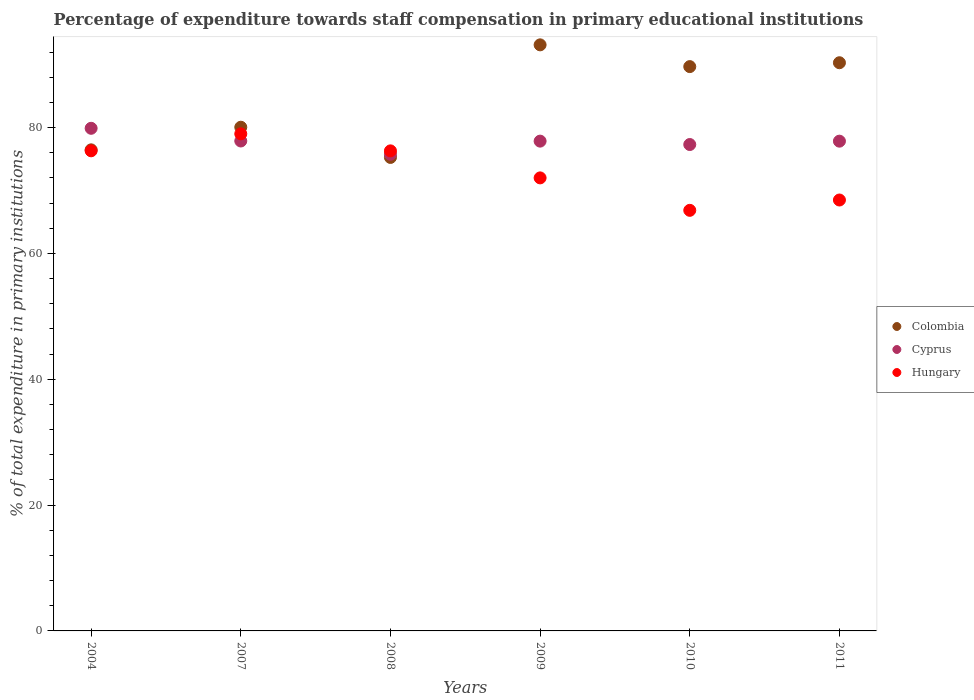What is the percentage of expenditure towards staff compensation in Cyprus in 2009?
Provide a succinct answer. 77.86. Across all years, what is the maximum percentage of expenditure towards staff compensation in Cyprus?
Offer a terse response. 79.89. Across all years, what is the minimum percentage of expenditure towards staff compensation in Colombia?
Offer a terse response. 75.26. In which year was the percentage of expenditure towards staff compensation in Colombia maximum?
Ensure brevity in your answer.  2009. In which year was the percentage of expenditure towards staff compensation in Colombia minimum?
Provide a succinct answer. 2008. What is the total percentage of expenditure towards staff compensation in Colombia in the graph?
Your answer should be compact. 504.98. What is the difference between the percentage of expenditure towards staff compensation in Colombia in 2004 and that in 2008?
Make the answer very short. 1.21. What is the difference between the percentage of expenditure towards staff compensation in Cyprus in 2011 and the percentage of expenditure towards staff compensation in Hungary in 2004?
Keep it short and to the point. 1.53. What is the average percentage of expenditure towards staff compensation in Hungary per year?
Provide a short and direct response. 73.17. In the year 2011, what is the difference between the percentage of expenditure towards staff compensation in Hungary and percentage of expenditure towards staff compensation in Cyprus?
Your response must be concise. -9.35. In how many years, is the percentage of expenditure towards staff compensation in Colombia greater than 84 %?
Your response must be concise. 3. What is the ratio of the percentage of expenditure towards staff compensation in Colombia in 2004 to that in 2010?
Give a very brief answer. 0.85. Is the percentage of expenditure towards staff compensation in Cyprus in 2008 less than that in 2011?
Ensure brevity in your answer.  Yes. What is the difference between the highest and the second highest percentage of expenditure towards staff compensation in Hungary?
Make the answer very short. 2.7. What is the difference between the highest and the lowest percentage of expenditure towards staff compensation in Cyprus?
Your answer should be very brief. 4.13. In how many years, is the percentage of expenditure towards staff compensation in Hungary greater than the average percentage of expenditure towards staff compensation in Hungary taken over all years?
Your answer should be very brief. 3. Does the percentage of expenditure towards staff compensation in Colombia monotonically increase over the years?
Your answer should be very brief. No. Is the percentage of expenditure towards staff compensation in Hungary strictly less than the percentage of expenditure towards staff compensation in Cyprus over the years?
Keep it short and to the point. No. How many years are there in the graph?
Provide a short and direct response. 6. Are the values on the major ticks of Y-axis written in scientific E-notation?
Your answer should be compact. No. Does the graph contain any zero values?
Make the answer very short. No. Where does the legend appear in the graph?
Provide a succinct answer. Center right. How many legend labels are there?
Offer a very short reply. 3. How are the legend labels stacked?
Offer a very short reply. Vertical. What is the title of the graph?
Provide a succinct answer. Percentage of expenditure towards staff compensation in primary educational institutions. What is the label or title of the Y-axis?
Your answer should be compact. % of total expenditure in primary institutions. What is the % of total expenditure in primary institutions of Colombia in 2004?
Provide a succinct answer. 76.47. What is the % of total expenditure in primary institutions of Cyprus in 2004?
Ensure brevity in your answer.  79.89. What is the % of total expenditure in primary institutions of Hungary in 2004?
Offer a terse response. 76.32. What is the % of total expenditure in primary institutions of Colombia in 2007?
Your response must be concise. 80.07. What is the % of total expenditure in primary institutions in Cyprus in 2007?
Your response must be concise. 77.88. What is the % of total expenditure in primary institutions in Hungary in 2007?
Make the answer very short. 79.01. What is the % of total expenditure in primary institutions of Colombia in 2008?
Give a very brief answer. 75.26. What is the % of total expenditure in primary institutions of Cyprus in 2008?
Give a very brief answer. 75.76. What is the % of total expenditure in primary institutions in Hungary in 2008?
Provide a succinct answer. 76.31. What is the % of total expenditure in primary institutions in Colombia in 2009?
Provide a succinct answer. 93.16. What is the % of total expenditure in primary institutions of Cyprus in 2009?
Your response must be concise. 77.86. What is the % of total expenditure in primary institutions in Hungary in 2009?
Provide a succinct answer. 72.01. What is the % of total expenditure in primary institutions in Colombia in 2010?
Provide a succinct answer. 89.7. What is the % of total expenditure in primary institutions of Cyprus in 2010?
Your answer should be very brief. 77.32. What is the % of total expenditure in primary institutions in Hungary in 2010?
Your response must be concise. 66.86. What is the % of total expenditure in primary institutions in Colombia in 2011?
Provide a succinct answer. 90.32. What is the % of total expenditure in primary institutions in Cyprus in 2011?
Your answer should be compact. 77.85. What is the % of total expenditure in primary institutions of Hungary in 2011?
Your response must be concise. 68.5. Across all years, what is the maximum % of total expenditure in primary institutions in Colombia?
Give a very brief answer. 93.16. Across all years, what is the maximum % of total expenditure in primary institutions in Cyprus?
Your response must be concise. 79.89. Across all years, what is the maximum % of total expenditure in primary institutions in Hungary?
Make the answer very short. 79.01. Across all years, what is the minimum % of total expenditure in primary institutions of Colombia?
Your answer should be very brief. 75.26. Across all years, what is the minimum % of total expenditure in primary institutions of Cyprus?
Offer a terse response. 75.76. Across all years, what is the minimum % of total expenditure in primary institutions of Hungary?
Your answer should be very brief. 66.86. What is the total % of total expenditure in primary institutions in Colombia in the graph?
Give a very brief answer. 504.98. What is the total % of total expenditure in primary institutions of Cyprus in the graph?
Ensure brevity in your answer.  466.55. What is the total % of total expenditure in primary institutions of Hungary in the graph?
Offer a very short reply. 439. What is the difference between the % of total expenditure in primary institutions of Colombia in 2004 and that in 2007?
Your response must be concise. -3.6. What is the difference between the % of total expenditure in primary institutions of Cyprus in 2004 and that in 2007?
Provide a succinct answer. 2.02. What is the difference between the % of total expenditure in primary institutions of Hungary in 2004 and that in 2007?
Ensure brevity in your answer.  -2.7. What is the difference between the % of total expenditure in primary institutions in Colombia in 2004 and that in 2008?
Provide a short and direct response. 1.21. What is the difference between the % of total expenditure in primary institutions in Cyprus in 2004 and that in 2008?
Your answer should be very brief. 4.13. What is the difference between the % of total expenditure in primary institutions of Hungary in 2004 and that in 2008?
Ensure brevity in your answer.  0.01. What is the difference between the % of total expenditure in primary institutions of Colombia in 2004 and that in 2009?
Give a very brief answer. -16.69. What is the difference between the % of total expenditure in primary institutions in Cyprus in 2004 and that in 2009?
Make the answer very short. 2.04. What is the difference between the % of total expenditure in primary institutions of Hungary in 2004 and that in 2009?
Provide a succinct answer. 4.31. What is the difference between the % of total expenditure in primary institutions in Colombia in 2004 and that in 2010?
Provide a short and direct response. -13.23. What is the difference between the % of total expenditure in primary institutions in Cyprus in 2004 and that in 2010?
Provide a succinct answer. 2.58. What is the difference between the % of total expenditure in primary institutions of Hungary in 2004 and that in 2010?
Offer a terse response. 9.46. What is the difference between the % of total expenditure in primary institutions of Colombia in 2004 and that in 2011?
Offer a very short reply. -13.85. What is the difference between the % of total expenditure in primary institutions in Cyprus in 2004 and that in 2011?
Provide a succinct answer. 2.04. What is the difference between the % of total expenditure in primary institutions in Hungary in 2004 and that in 2011?
Provide a succinct answer. 7.82. What is the difference between the % of total expenditure in primary institutions of Colombia in 2007 and that in 2008?
Give a very brief answer. 4.8. What is the difference between the % of total expenditure in primary institutions in Cyprus in 2007 and that in 2008?
Make the answer very short. 2.12. What is the difference between the % of total expenditure in primary institutions in Hungary in 2007 and that in 2008?
Your response must be concise. 2.71. What is the difference between the % of total expenditure in primary institutions of Colombia in 2007 and that in 2009?
Offer a terse response. -13.09. What is the difference between the % of total expenditure in primary institutions in Cyprus in 2007 and that in 2009?
Make the answer very short. 0.02. What is the difference between the % of total expenditure in primary institutions in Hungary in 2007 and that in 2009?
Your answer should be compact. 7. What is the difference between the % of total expenditure in primary institutions of Colombia in 2007 and that in 2010?
Offer a very short reply. -9.64. What is the difference between the % of total expenditure in primary institutions of Cyprus in 2007 and that in 2010?
Your answer should be very brief. 0.56. What is the difference between the % of total expenditure in primary institutions of Hungary in 2007 and that in 2010?
Offer a very short reply. 12.16. What is the difference between the % of total expenditure in primary institutions of Colombia in 2007 and that in 2011?
Your answer should be compact. -10.25. What is the difference between the % of total expenditure in primary institutions in Cyprus in 2007 and that in 2011?
Provide a short and direct response. 0.03. What is the difference between the % of total expenditure in primary institutions in Hungary in 2007 and that in 2011?
Your response must be concise. 10.52. What is the difference between the % of total expenditure in primary institutions in Colombia in 2008 and that in 2009?
Offer a very short reply. -17.9. What is the difference between the % of total expenditure in primary institutions in Cyprus in 2008 and that in 2009?
Offer a terse response. -2.09. What is the difference between the % of total expenditure in primary institutions of Hungary in 2008 and that in 2009?
Provide a succinct answer. 4.3. What is the difference between the % of total expenditure in primary institutions in Colombia in 2008 and that in 2010?
Your answer should be very brief. -14.44. What is the difference between the % of total expenditure in primary institutions in Cyprus in 2008 and that in 2010?
Give a very brief answer. -1.56. What is the difference between the % of total expenditure in primary institutions of Hungary in 2008 and that in 2010?
Offer a very short reply. 9.45. What is the difference between the % of total expenditure in primary institutions of Colombia in 2008 and that in 2011?
Your answer should be compact. -15.05. What is the difference between the % of total expenditure in primary institutions in Cyprus in 2008 and that in 2011?
Give a very brief answer. -2.09. What is the difference between the % of total expenditure in primary institutions of Hungary in 2008 and that in 2011?
Provide a succinct answer. 7.81. What is the difference between the % of total expenditure in primary institutions in Colombia in 2009 and that in 2010?
Keep it short and to the point. 3.46. What is the difference between the % of total expenditure in primary institutions of Cyprus in 2009 and that in 2010?
Provide a succinct answer. 0.54. What is the difference between the % of total expenditure in primary institutions of Hungary in 2009 and that in 2010?
Your answer should be compact. 5.16. What is the difference between the % of total expenditure in primary institutions of Colombia in 2009 and that in 2011?
Keep it short and to the point. 2.84. What is the difference between the % of total expenditure in primary institutions in Cyprus in 2009 and that in 2011?
Offer a very short reply. 0.01. What is the difference between the % of total expenditure in primary institutions in Hungary in 2009 and that in 2011?
Ensure brevity in your answer.  3.52. What is the difference between the % of total expenditure in primary institutions in Colombia in 2010 and that in 2011?
Your answer should be very brief. -0.62. What is the difference between the % of total expenditure in primary institutions of Cyprus in 2010 and that in 2011?
Your answer should be compact. -0.53. What is the difference between the % of total expenditure in primary institutions of Hungary in 2010 and that in 2011?
Your answer should be very brief. -1.64. What is the difference between the % of total expenditure in primary institutions of Colombia in 2004 and the % of total expenditure in primary institutions of Cyprus in 2007?
Give a very brief answer. -1.41. What is the difference between the % of total expenditure in primary institutions of Colombia in 2004 and the % of total expenditure in primary institutions of Hungary in 2007?
Provide a succinct answer. -2.54. What is the difference between the % of total expenditure in primary institutions in Cyprus in 2004 and the % of total expenditure in primary institutions in Hungary in 2007?
Provide a short and direct response. 0.88. What is the difference between the % of total expenditure in primary institutions of Colombia in 2004 and the % of total expenditure in primary institutions of Cyprus in 2008?
Your response must be concise. 0.71. What is the difference between the % of total expenditure in primary institutions in Colombia in 2004 and the % of total expenditure in primary institutions in Hungary in 2008?
Your answer should be compact. 0.16. What is the difference between the % of total expenditure in primary institutions of Cyprus in 2004 and the % of total expenditure in primary institutions of Hungary in 2008?
Offer a terse response. 3.59. What is the difference between the % of total expenditure in primary institutions in Colombia in 2004 and the % of total expenditure in primary institutions in Cyprus in 2009?
Provide a succinct answer. -1.38. What is the difference between the % of total expenditure in primary institutions of Colombia in 2004 and the % of total expenditure in primary institutions of Hungary in 2009?
Make the answer very short. 4.46. What is the difference between the % of total expenditure in primary institutions of Cyprus in 2004 and the % of total expenditure in primary institutions of Hungary in 2009?
Offer a very short reply. 7.88. What is the difference between the % of total expenditure in primary institutions in Colombia in 2004 and the % of total expenditure in primary institutions in Cyprus in 2010?
Ensure brevity in your answer.  -0.85. What is the difference between the % of total expenditure in primary institutions in Colombia in 2004 and the % of total expenditure in primary institutions in Hungary in 2010?
Make the answer very short. 9.62. What is the difference between the % of total expenditure in primary institutions in Cyprus in 2004 and the % of total expenditure in primary institutions in Hungary in 2010?
Offer a very short reply. 13.04. What is the difference between the % of total expenditure in primary institutions in Colombia in 2004 and the % of total expenditure in primary institutions in Cyprus in 2011?
Make the answer very short. -1.38. What is the difference between the % of total expenditure in primary institutions in Colombia in 2004 and the % of total expenditure in primary institutions in Hungary in 2011?
Make the answer very short. 7.97. What is the difference between the % of total expenditure in primary institutions of Cyprus in 2004 and the % of total expenditure in primary institutions of Hungary in 2011?
Your response must be concise. 11.4. What is the difference between the % of total expenditure in primary institutions in Colombia in 2007 and the % of total expenditure in primary institutions in Cyprus in 2008?
Offer a very short reply. 4.31. What is the difference between the % of total expenditure in primary institutions of Colombia in 2007 and the % of total expenditure in primary institutions of Hungary in 2008?
Keep it short and to the point. 3.76. What is the difference between the % of total expenditure in primary institutions in Cyprus in 2007 and the % of total expenditure in primary institutions in Hungary in 2008?
Provide a short and direct response. 1.57. What is the difference between the % of total expenditure in primary institutions of Colombia in 2007 and the % of total expenditure in primary institutions of Cyprus in 2009?
Provide a succinct answer. 2.21. What is the difference between the % of total expenditure in primary institutions of Colombia in 2007 and the % of total expenditure in primary institutions of Hungary in 2009?
Make the answer very short. 8.05. What is the difference between the % of total expenditure in primary institutions in Cyprus in 2007 and the % of total expenditure in primary institutions in Hungary in 2009?
Your answer should be very brief. 5.87. What is the difference between the % of total expenditure in primary institutions of Colombia in 2007 and the % of total expenditure in primary institutions of Cyprus in 2010?
Offer a terse response. 2.75. What is the difference between the % of total expenditure in primary institutions in Colombia in 2007 and the % of total expenditure in primary institutions in Hungary in 2010?
Provide a succinct answer. 13.21. What is the difference between the % of total expenditure in primary institutions of Cyprus in 2007 and the % of total expenditure in primary institutions of Hungary in 2010?
Your answer should be compact. 11.02. What is the difference between the % of total expenditure in primary institutions in Colombia in 2007 and the % of total expenditure in primary institutions in Cyprus in 2011?
Offer a very short reply. 2.22. What is the difference between the % of total expenditure in primary institutions in Colombia in 2007 and the % of total expenditure in primary institutions in Hungary in 2011?
Ensure brevity in your answer.  11.57. What is the difference between the % of total expenditure in primary institutions of Cyprus in 2007 and the % of total expenditure in primary institutions of Hungary in 2011?
Give a very brief answer. 9.38. What is the difference between the % of total expenditure in primary institutions in Colombia in 2008 and the % of total expenditure in primary institutions in Cyprus in 2009?
Provide a succinct answer. -2.59. What is the difference between the % of total expenditure in primary institutions of Colombia in 2008 and the % of total expenditure in primary institutions of Hungary in 2009?
Your answer should be compact. 3.25. What is the difference between the % of total expenditure in primary institutions of Cyprus in 2008 and the % of total expenditure in primary institutions of Hungary in 2009?
Your answer should be very brief. 3.75. What is the difference between the % of total expenditure in primary institutions in Colombia in 2008 and the % of total expenditure in primary institutions in Cyprus in 2010?
Keep it short and to the point. -2.05. What is the difference between the % of total expenditure in primary institutions of Colombia in 2008 and the % of total expenditure in primary institutions of Hungary in 2010?
Offer a terse response. 8.41. What is the difference between the % of total expenditure in primary institutions in Cyprus in 2008 and the % of total expenditure in primary institutions in Hungary in 2010?
Make the answer very short. 8.91. What is the difference between the % of total expenditure in primary institutions of Colombia in 2008 and the % of total expenditure in primary institutions of Cyprus in 2011?
Your answer should be compact. -2.59. What is the difference between the % of total expenditure in primary institutions of Colombia in 2008 and the % of total expenditure in primary institutions of Hungary in 2011?
Offer a very short reply. 6.77. What is the difference between the % of total expenditure in primary institutions of Cyprus in 2008 and the % of total expenditure in primary institutions of Hungary in 2011?
Offer a very short reply. 7.26. What is the difference between the % of total expenditure in primary institutions of Colombia in 2009 and the % of total expenditure in primary institutions of Cyprus in 2010?
Your answer should be compact. 15.84. What is the difference between the % of total expenditure in primary institutions of Colombia in 2009 and the % of total expenditure in primary institutions of Hungary in 2010?
Your response must be concise. 26.3. What is the difference between the % of total expenditure in primary institutions in Cyprus in 2009 and the % of total expenditure in primary institutions in Hungary in 2010?
Your response must be concise. 11. What is the difference between the % of total expenditure in primary institutions in Colombia in 2009 and the % of total expenditure in primary institutions in Cyprus in 2011?
Keep it short and to the point. 15.31. What is the difference between the % of total expenditure in primary institutions in Colombia in 2009 and the % of total expenditure in primary institutions in Hungary in 2011?
Ensure brevity in your answer.  24.66. What is the difference between the % of total expenditure in primary institutions of Cyprus in 2009 and the % of total expenditure in primary institutions of Hungary in 2011?
Give a very brief answer. 9.36. What is the difference between the % of total expenditure in primary institutions of Colombia in 2010 and the % of total expenditure in primary institutions of Cyprus in 2011?
Make the answer very short. 11.85. What is the difference between the % of total expenditure in primary institutions of Colombia in 2010 and the % of total expenditure in primary institutions of Hungary in 2011?
Provide a short and direct response. 21.21. What is the difference between the % of total expenditure in primary institutions in Cyprus in 2010 and the % of total expenditure in primary institutions in Hungary in 2011?
Make the answer very short. 8.82. What is the average % of total expenditure in primary institutions of Colombia per year?
Offer a terse response. 84.16. What is the average % of total expenditure in primary institutions in Cyprus per year?
Your answer should be compact. 77.76. What is the average % of total expenditure in primary institutions of Hungary per year?
Ensure brevity in your answer.  73.17. In the year 2004, what is the difference between the % of total expenditure in primary institutions in Colombia and % of total expenditure in primary institutions in Cyprus?
Your answer should be very brief. -3.42. In the year 2004, what is the difference between the % of total expenditure in primary institutions of Colombia and % of total expenditure in primary institutions of Hungary?
Provide a short and direct response. 0.15. In the year 2004, what is the difference between the % of total expenditure in primary institutions in Cyprus and % of total expenditure in primary institutions in Hungary?
Ensure brevity in your answer.  3.58. In the year 2007, what is the difference between the % of total expenditure in primary institutions of Colombia and % of total expenditure in primary institutions of Cyprus?
Give a very brief answer. 2.19. In the year 2007, what is the difference between the % of total expenditure in primary institutions of Colombia and % of total expenditure in primary institutions of Hungary?
Keep it short and to the point. 1.05. In the year 2007, what is the difference between the % of total expenditure in primary institutions of Cyprus and % of total expenditure in primary institutions of Hungary?
Give a very brief answer. -1.14. In the year 2008, what is the difference between the % of total expenditure in primary institutions of Colombia and % of total expenditure in primary institutions of Cyprus?
Offer a very short reply. -0.5. In the year 2008, what is the difference between the % of total expenditure in primary institutions in Colombia and % of total expenditure in primary institutions in Hungary?
Your answer should be compact. -1.05. In the year 2008, what is the difference between the % of total expenditure in primary institutions in Cyprus and % of total expenditure in primary institutions in Hungary?
Provide a short and direct response. -0.55. In the year 2009, what is the difference between the % of total expenditure in primary institutions in Colombia and % of total expenditure in primary institutions in Cyprus?
Your answer should be compact. 15.3. In the year 2009, what is the difference between the % of total expenditure in primary institutions of Colombia and % of total expenditure in primary institutions of Hungary?
Your response must be concise. 21.15. In the year 2009, what is the difference between the % of total expenditure in primary institutions in Cyprus and % of total expenditure in primary institutions in Hungary?
Offer a terse response. 5.84. In the year 2010, what is the difference between the % of total expenditure in primary institutions of Colombia and % of total expenditure in primary institutions of Cyprus?
Your answer should be very brief. 12.38. In the year 2010, what is the difference between the % of total expenditure in primary institutions in Colombia and % of total expenditure in primary institutions in Hungary?
Your response must be concise. 22.85. In the year 2010, what is the difference between the % of total expenditure in primary institutions of Cyprus and % of total expenditure in primary institutions of Hungary?
Offer a terse response. 10.46. In the year 2011, what is the difference between the % of total expenditure in primary institutions in Colombia and % of total expenditure in primary institutions in Cyprus?
Offer a terse response. 12.47. In the year 2011, what is the difference between the % of total expenditure in primary institutions of Colombia and % of total expenditure in primary institutions of Hungary?
Ensure brevity in your answer.  21.82. In the year 2011, what is the difference between the % of total expenditure in primary institutions in Cyprus and % of total expenditure in primary institutions in Hungary?
Make the answer very short. 9.35. What is the ratio of the % of total expenditure in primary institutions of Colombia in 2004 to that in 2007?
Your answer should be very brief. 0.96. What is the ratio of the % of total expenditure in primary institutions in Cyprus in 2004 to that in 2007?
Your response must be concise. 1.03. What is the ratio of the % of total expenditure in primary institutions of Hungary in 2004 to that in 2007?
Your answer should be compact. 0.97. What is the ratio of the % of total expenditure in primary institutions of Colombia in 2004 to that in 2008?
Your answer should be compact. 1.02. What is the ratio of the % of total expenditure in primary institutions in Cyprus in 2004 to that in 2008?
Give a very brief answer. 1.05. What is the ratio of the % of total expenditure in primary institutions in Hungary in 2004 to that in 2008?
Keep it short and to the point. 1. What is the ratio of the % of total expenditure in primary institutions in Colombia in 2004 to that in 2009?
Provide a succinct answer. 0.82. What is the ratio of the % of total expenditure in primary institutions in Cyprus in 2004 to that in 2009?
Your answer should be very brief. 1.03. What is the ratio of the % of total expenditure in primary institutions in Hungary in 2004 to that in 2009?
Your response must be concise. 1.06. What is the ratio of the % of total expenditure in primary institutions in Colombia in 2004 to that in 2010?
Ensure brevity in your answer.  0.85. What is the ratio of the % of total expenditure in primary institutions in Cyprus in 2004 to that in 2010?
Offer a very short reply. 1.03. What is the ratio of the % of total expenditure in primary institutions in Hungary in 2004 to that in 2010?
Your answer should be very brief. 1.14. What is the ratio of the % of total expenditure in primary institutions in Colombia in 2004 to that in 2011?
Provide a short and direct response. 0.85. What is the ratio of the % of total expenditure in primary institutions of Cyprus in 2004 to that in 2011?
Your response must be concise. 1.03. What is the ratio of the % of total expenditure in primary institutions of Hungary in 2004 to that in 2011?
Offer a very short reply. 1.11. What is the ratio of the % of total expenditure in primary institutions in Colombia in 2007 to that in 2008?
Give a very brief answer. 1.06. What is the ratio of the % of total expenditure in primary institutions of Cyprus in 2007 to that in 2008?
Your answer should be compact. 1.03. What is the ratio of the % of total expenditure in primary institutions in Hungary in 2007 to that in 2008?
Provide a succinct answer. 1.04. What is the ratio of the % of total expenditure in primary institutions of Colombia in 2007 to that in 2009?
Offer a terse response. 0.86. What is the ratio of the % of total expenditure in primary institutions in Hungary in 2007 to that in 2009?
Keep it short and to the point. 1.1. What is the ratio of the % of total expenditure in primary institutions of Colombia in 2007 to that in 2010?
Offer a very short reply. 0.89. What is the ratio of the % of total expenditure in primary institutions in Cyprus in 2007 to that in 2010?
Your response must be concise. 1.01. What is the ratio of the % of total expenditure in primary institutions of Hungary in 2007 to that in 2010?
Your response must be concise. 1.18. What is the ratio of the % of total expenditure in primary institutions in Colombia in 2007 to that in 2011?
Offer a terse response. 0.89. What is the ratio of the % of total expenditure in primary institutions in Cyprus in 2007 to that in 2011?
Make the answer very short. 1. What is the ratio of the % of total expenditure in primary institutions of Hungary in 2007 to that in 2011?
Give a very brief answer. 1.15. What is the ratio of the % of total expenditure in primary institutions in Colombia in 2008 to that in 2009?
Provide a short and direct response. 0.81. What is the ratio of the % of total expenditure in primary institutions of Cyprus in 2008 to that in 2009?
Make the answer very short. 0.97. What is the ratio of the % of total expenditure in primary institutions in Hungary in 2008 to that in 2009?
Your answer should be compact. 1.06. What is the ratio of the % of total expenditure in primary institutions in Colombia in 2008 to that in 2010?
Offer a very short reply. 0.84. What is the ratio of the % of total expenditure in primary institutions of Cyprus in 2008 to that in 2010?
Your answer should be very brief. 0.98. What is the ratio of the % of total expenditure in primary institutions of Hungary in 2008 to that in 2010?
Keep it short and to the point. 1.14. What is the ratio of the % of total expenditure in primary institutions in Cyprus in 2008 to that in 2011?
Offer a terse response. 0.97. What is the ratio of the % of total expenditure in primary institutions of Hungary in 2008 to that in 2011?
Ensure brevity in your answer.  1.11. What is the ratio of the % of total expenditure in primary institutions of Colombia in 2009 to that in 2010?
Provide a short and direct response. 1.04. What is the ratio of the % of total expenditure in primary institutions of Cyprus in 2009 to that in 2010?
Provide a succinct answer. 1.01. What is the ratio of the % of total expenditure in primary institutions in Hungary in 2009 to that in 2010?
Offer a very short reply. 1.08. What is the ratio of the % of total expenditure in primary institutions in Colombia in 2009 to that in 2011?
Provide a succinct answer. 1.03. What is the ratio of the % of total expenditure in primary institutions in Hungary in 2009 to that in 2011?
Offer a terse response. 1.05. What is the ratio of the % of total expenditure in primary institutions of Colombia in 2010 to that in 2011?
Ensure brevity in your answer.  0.99. What is the ratio of the % of total expenditure in primary institutions in Hungary in 2010 to that in 2011?
Provide a succinct answer. 0.98. What is the difference between the highest and the second highest % of total expenditure in primary institutions in Colombia?
Ensure brevity in your answer.  2.84. What is the difference between the highest and the second highest % of total expenditure in primary institutions of Cyprus?
Keep it short and to the point. 2.02. What is the difference between the highest and the second highest % of total expenditure in primary institutions in Hungary?
Give a very brief answer. 2.7. What is the difference between the highest and the lowest % of total expenditure in primary institutions of Colombia?
Make the answer very short. 17.9. What is the difference between the highest and the lowest % of total expenditure in primary institutions in Cyprus?
Make the answer very short. 4.13. What is the difference between the highest and the lowest % of total expenditure in primary institutions in Hungary?
Offer a very short reply. 12.16. 